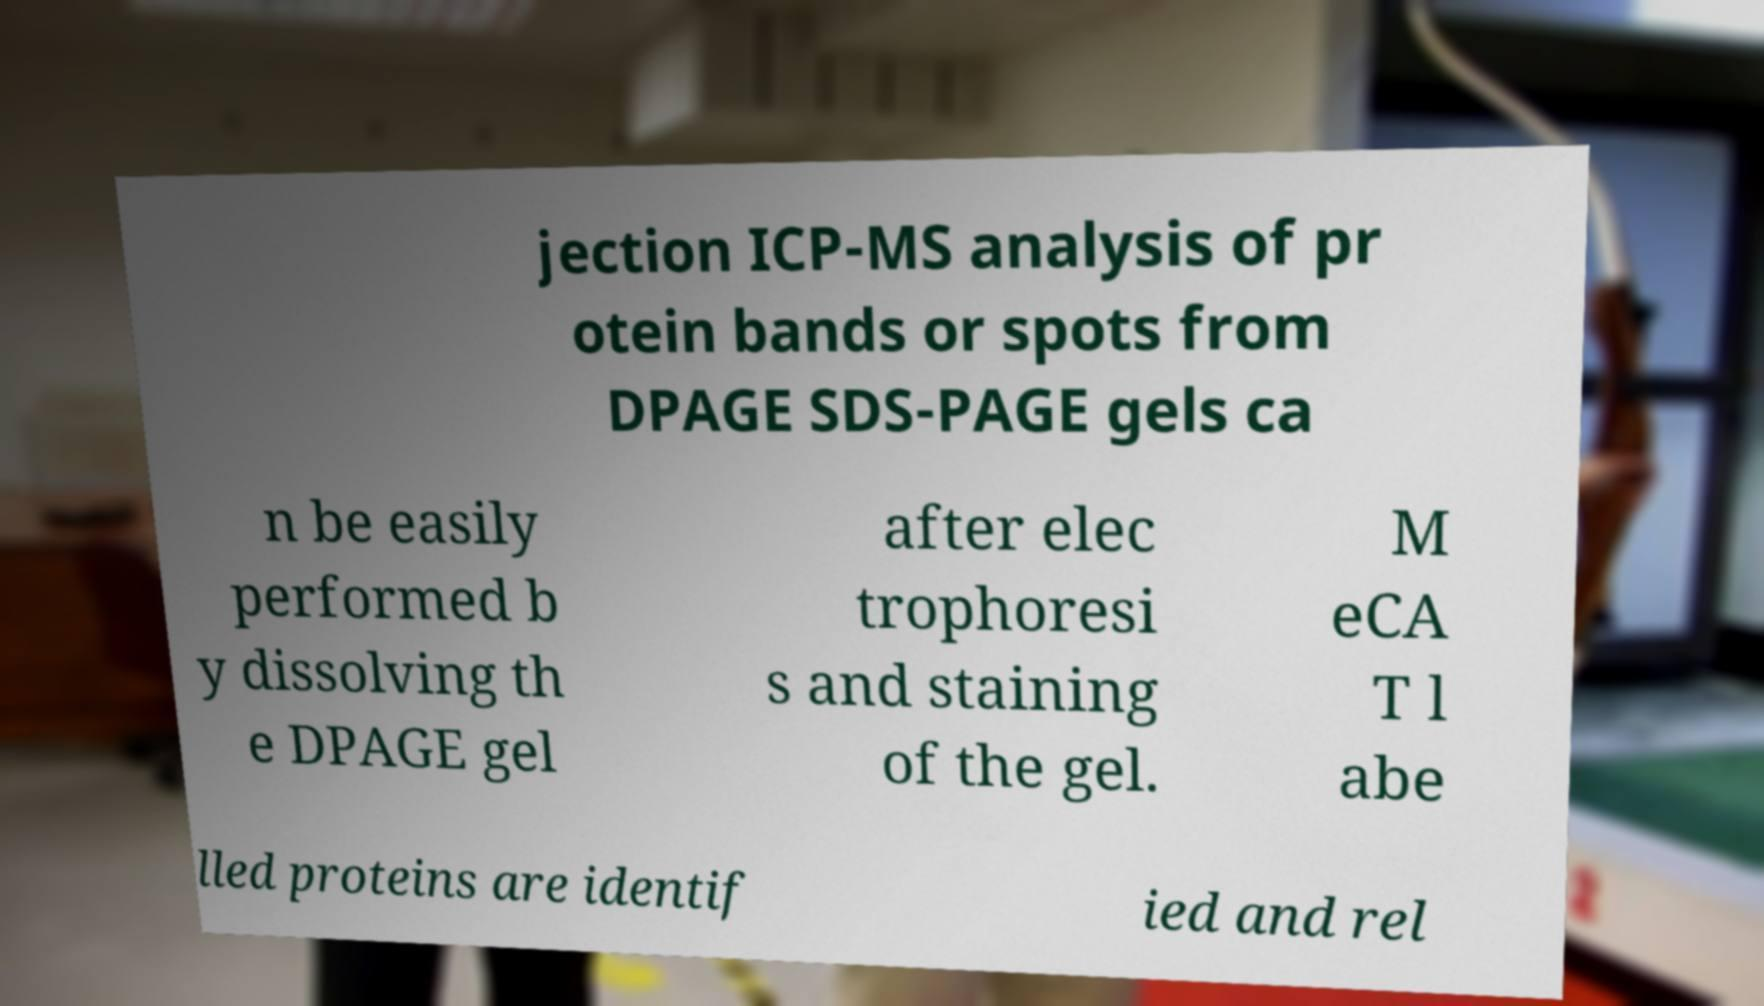There's text embedded in this image that I need extracted. Can you transcribe it verbatim? jection ICP-MS analysis of pr otein bands or spots from DPAGE SDS-PAGE gels ca n be easily performed b y dissolving th e DPAGE gel after elec trophoresi s and staining of the gel. M eCA T l abe lled proteins are identif ied and rel 